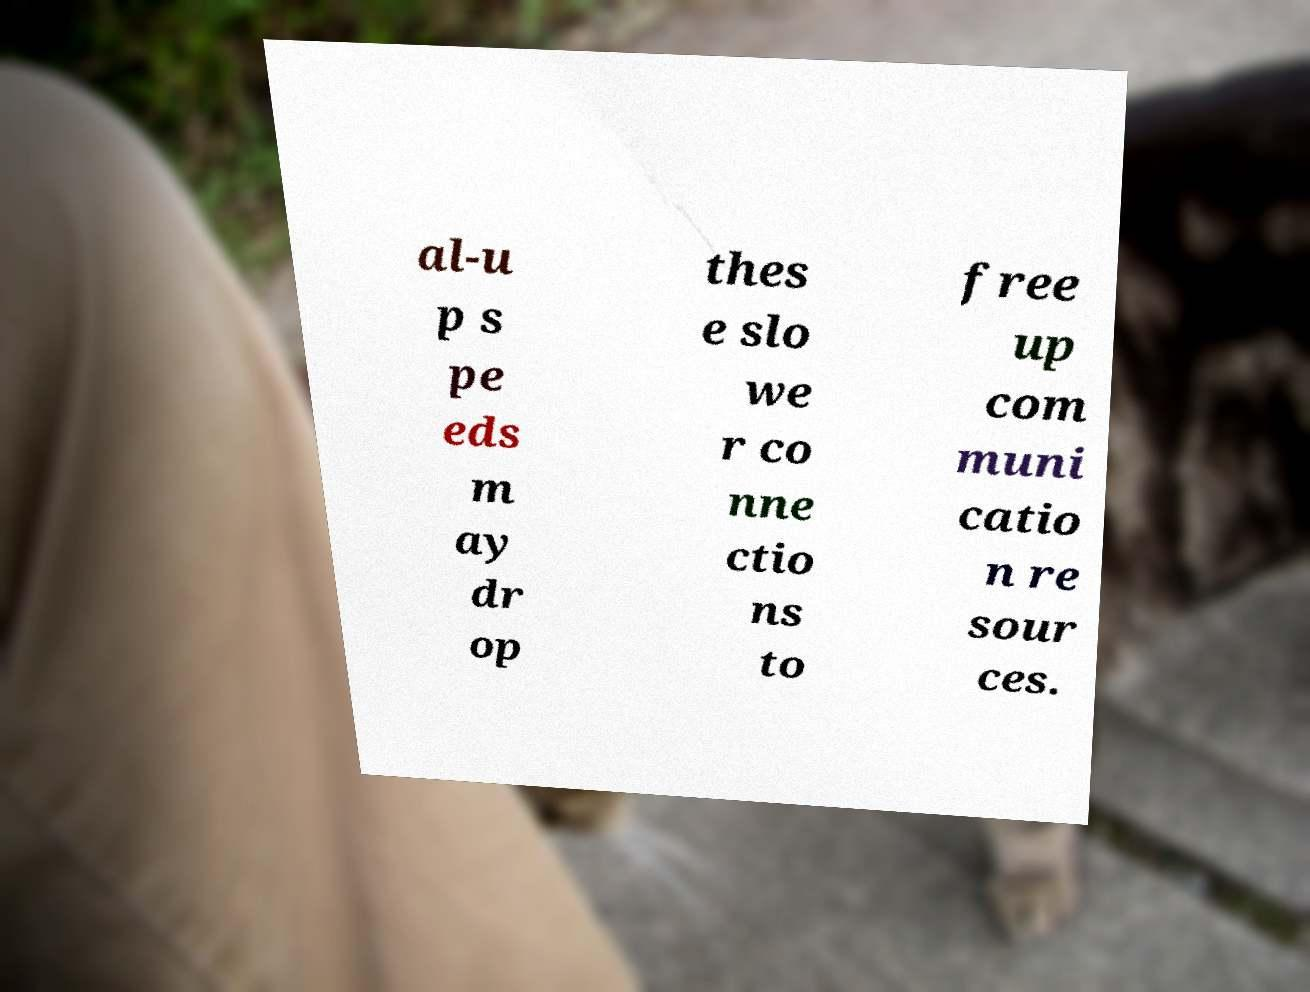Please identify and transcribe the text found in this image. al-u p s pe eds m ay dr op thes e slo we r co nne ctio ns to free up com muni catio n re sour ces. 